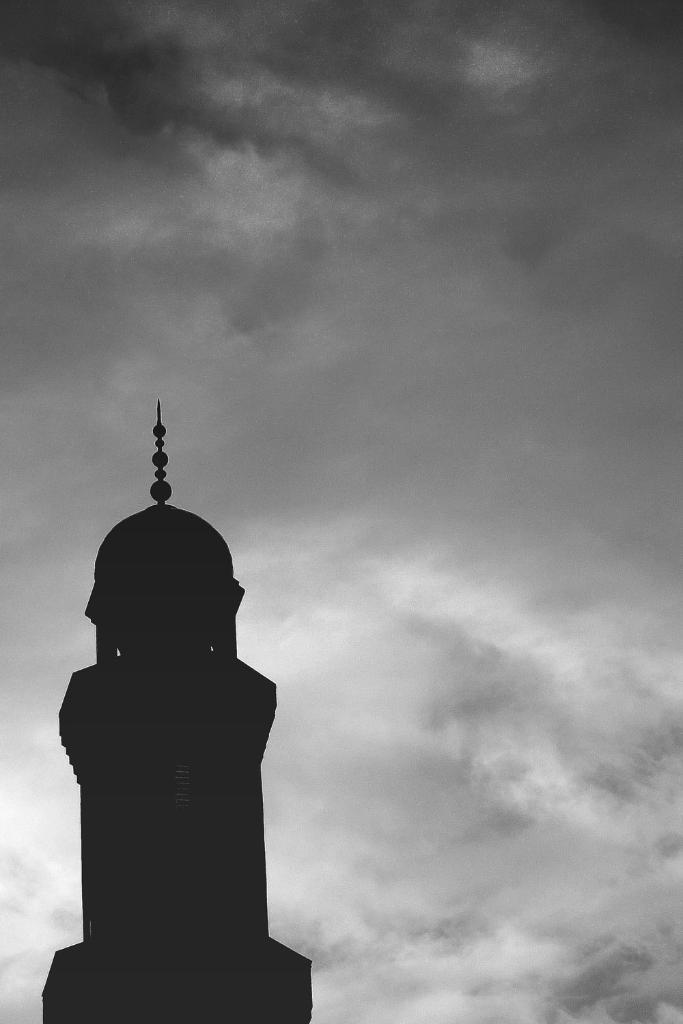What is the main structure visible in the front of the image? There is a tower in the front of the image. What is the condition of the sky in the background? The sky in the background is cloudy. Can you see a bell hanging from the tower in the image? There is no bell visible hanging from the tower in the image. Is there an island in the background of the image? There is no island present in the image; it features a tower and a cloudy sky in the background. 